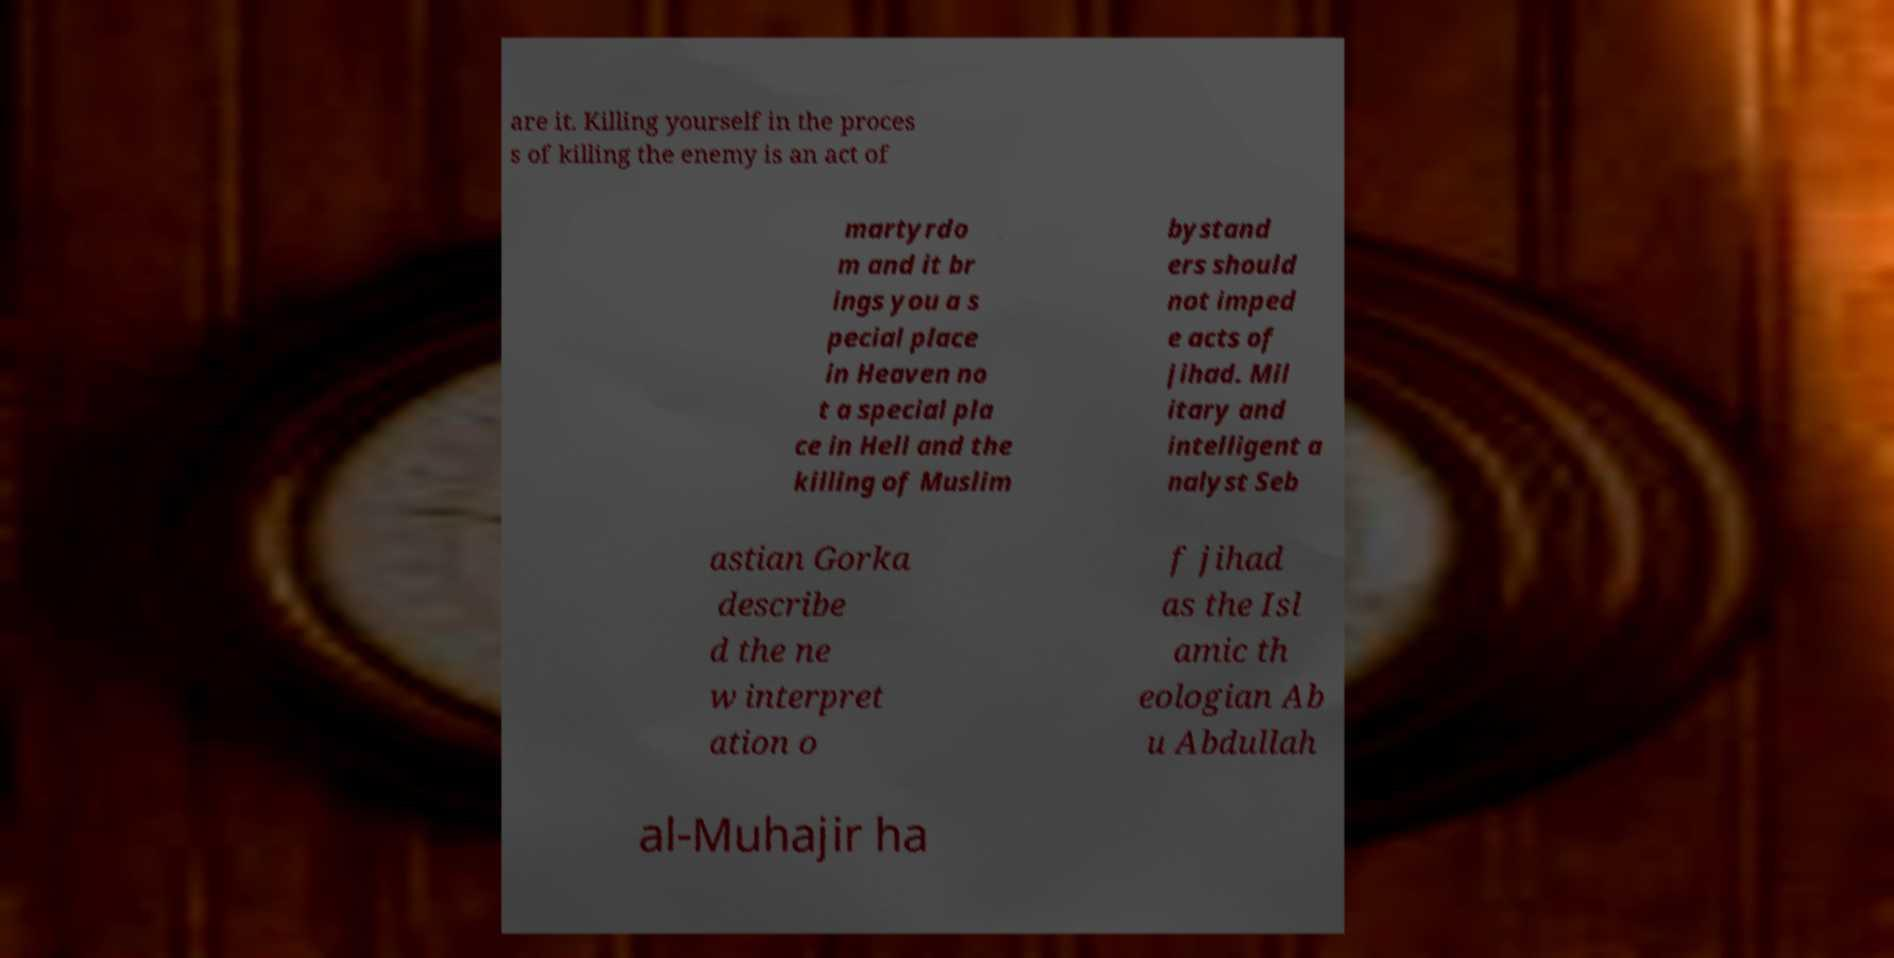Can you read and provide the text displayed in the image?This photo seems to have some interesting text. Can you extract and type it out for me? are it. Killing yourself in the proces s of killing the enemy is an act of martyrdo m and it br ings you a s pecial place in Heaven no t a special pla ce in Hell and the killing of Muslim bystand ers should not imped e acts of jihad. Mil itary and intelligent a nalyst Seb astian Gorka describe d the ne w interpret ation o f jihad as the Isl amic th eologian Ab u Abdullah al-Muhajir ha 